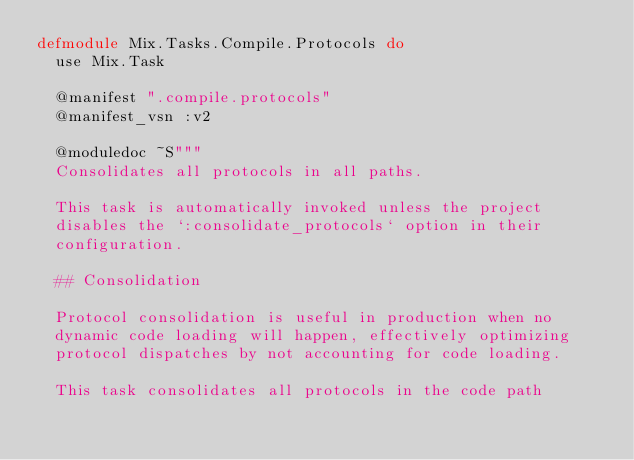<code> <loc_0><loc_0><loc_500><loc_500><_Elixir_>defmodule Mix.Tasks.Compile.Protocols do
  use Mix.Task

  @manifest ".compile.protocols"
  @manifest_vsn :v2

  @moduledoc ~S"""
  Consolidates all protocols in all paths.

  This task is automatically invoked unless the project
  disables the `:consolidate_protocols` option in their
  configuration.

  ## Consolidation

  Protocol consolidation is useful in production when no
  dynamic code loading will happen, effectively optimizing
  protocol dispatches by not accounting for code loading.

  This task consolidates all protocols in the code path</code> 